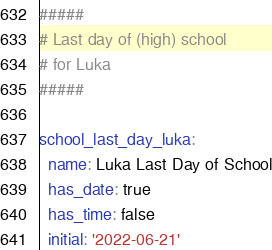Convert code to text. <code><loc_0><loc_0><loc_500><loc_500><_YAML_>#####
# Last day of (high) school
# for Luka
#####

school_last_day_luka:
  name: Luka Last Day of School
  has_date: true
  has_time: false
  initial: '2022-06-21'
</code> 